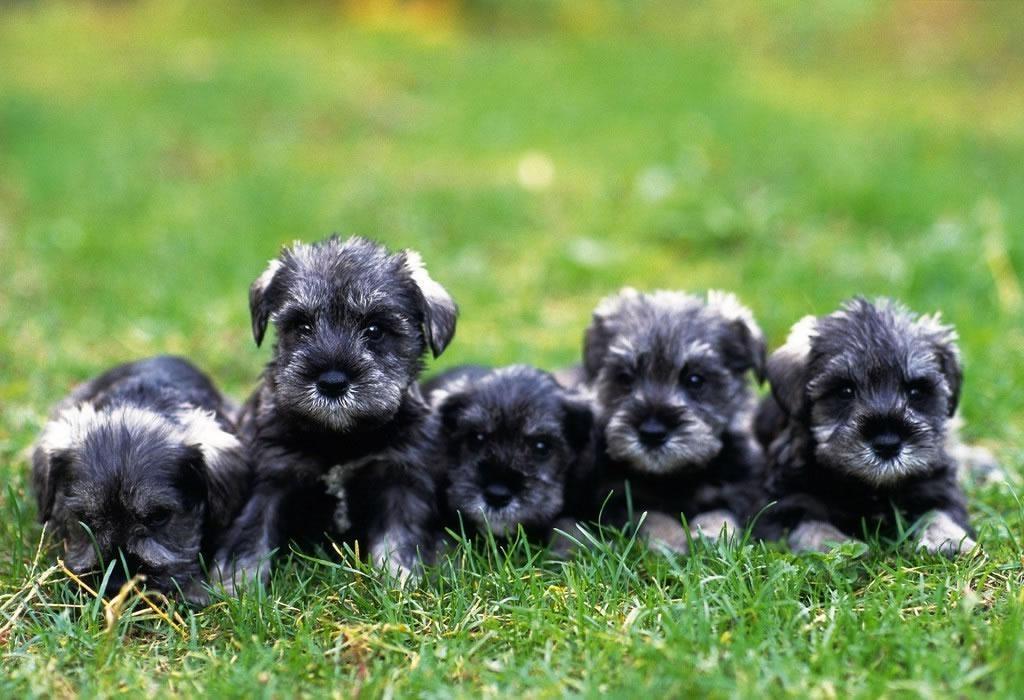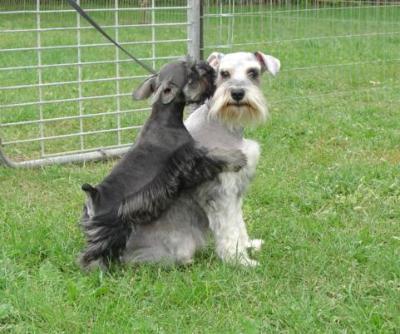The first image is the image on the left, the second image is the image on the right. Analyze the images presented: Is the assertion "Two dogs are playing in the grass in at least one of the images." valid? Answer yes or no. Yes. The first image is the image on the left, the second image is the image on the right. Analyze the images presented: Is the assertion "A ball is in the grass in front of a dog in one image." valid? Answer yes or no. No. 